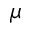<formula> <loc_0><loc_0><loc_500><loc_500>\mu</formula> 